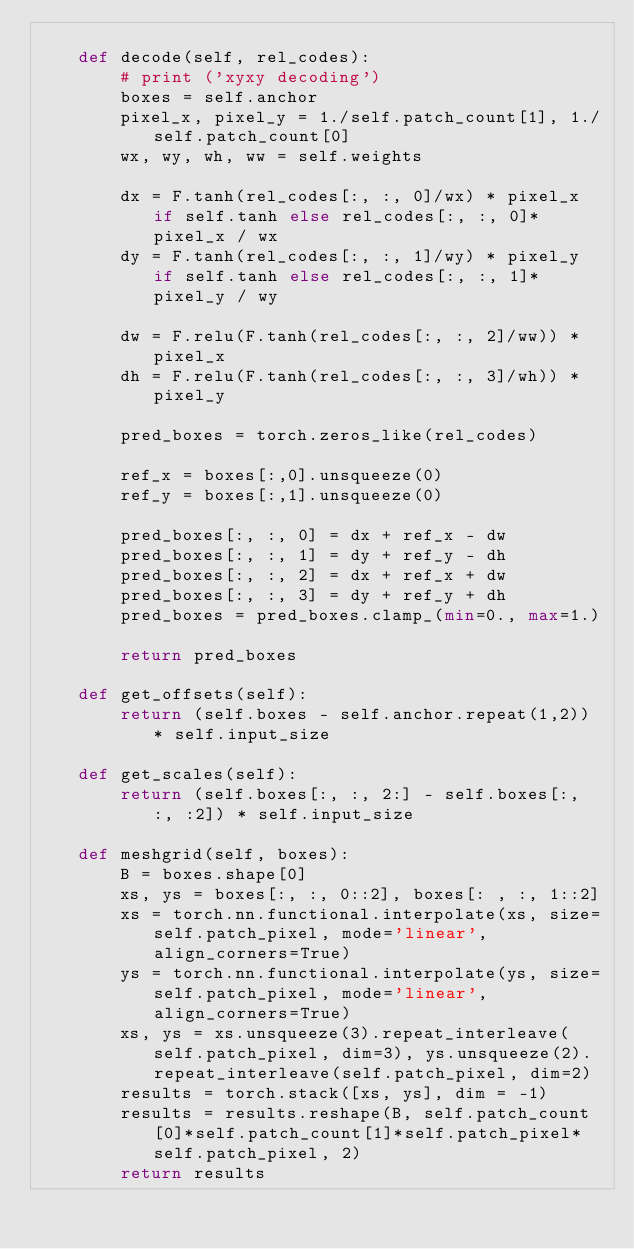Convert code to text. <code><loc_0><loc_0><loc_500><loc_500><_Python_>
    def decode(self, rel_codes):
        # print ('xyxy decoding')
        boxes = self.anchor
        pixel_x, pixel_y = 1./self.patch_count[1], 1./self.patch_count[0]
        wx, wy, wh, ww = self.weights

        dx = F.tanh(rel_codes[:, :, 0]/wx) * pixel_x if self.tanh else rel_codes[:, :, 0]*pixel_x / wx
        dy = F.tanh(rel_codes[:, :, 1]/wy) * pixel_y if self.tanh else rel_codes[:, :, 1]*pixel_y / wy

        dw = F.relu(F.tanh(rel_codes[:, :, 2]/ww)) * pixel_x
        dh = F.relu(F.tanh(rel_codes[:, :, 3]/wh)) * pixel_y

        pred_boxes = torch.zeros_like(rel_codes)

        ref_x = boxes[:,0].unsqueeze(0)
        ref_y = boxes[:,1].unsqueeze(0)

        pred_boxes[:, :, 0] = dx + ref_x - dw
        pred_boxes[:, :, 1] = dy + ref_y - dh
        pred_boxes[:, :, 2] = dx + ref_x + dw
        pred_boxes[:, :, 3] = dy + ref_y + dh
        pred_boxes = pred_boxes.clamp_(min=0., max=1.)

        return pred_boxes

    def get_offsets(self):
        return (self.boxes - self.anchor.repeat(1,2)) * self.input_size

    def get_scales(self):
        return (self.boxes[:, :, 2:] - self.boxes[:, :, :2]) * self.input_size
    
    def meshgrid(self, boxes):
        B = boxes.shape[0]
        xs, ys = boxes[:, :, 0::2], boxes[: , :, 1::2]
        xs = torch.nn.functional.interpolate(xs, size=self.patch_pixel, mode='linear', align_corners=True)
        ys = torch.nn.functional.interpolate(ys, size=self.patch_pixel, mode='linear', align_corners=True)
        xs, ys = xs.unsqueeze(3).repeat_interleave(self.patch_pixel, dim=3), ys.unsqueeze(2).repeat_interleave(self.patch_pixel, dim=2)
        results = torch.stack([xs, ys], dim = -1)
        results = results.reshape(B, self.patch_count[0]*self.patch_count[1]*self.patch_pixel*self.patch_pixel, 2)
        return results
</code> 